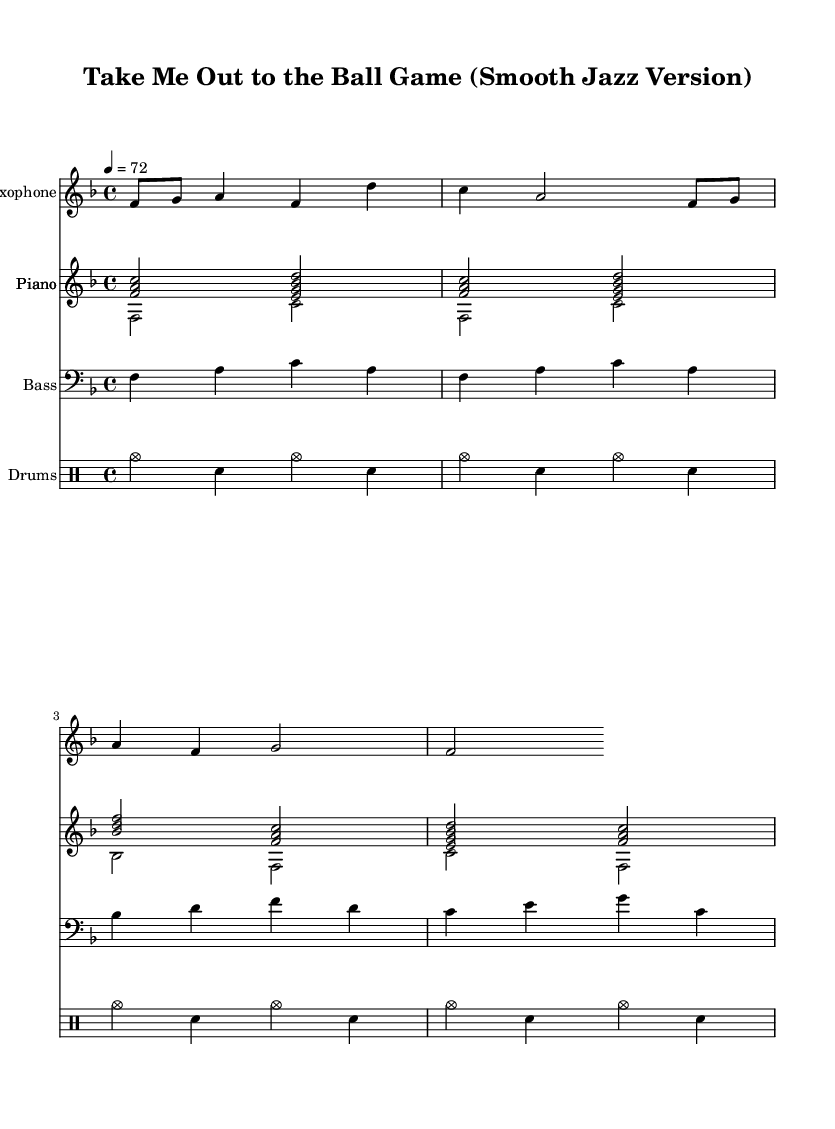What is the key signature of this music? The key signature indicates F major, which has one flat (B flat). This information is found at the beginning of the staff notation, where the flat symbol appears.
Answer: F major What is the time signature of this music? The time signature is indicated by the fraction at the beginning of the sheet music. In this case, it shows 4 over 4, meaning there are four beats in each measure.
Answer: 4/4 What is the tempo of this music? The tempo is shown next to the time signature, where it specifies '4 = 72', indicating that the quarter note equals 72 beats per minute.
Answer: 72 How many measures are in the saxophone part? To determine the number of measures, count the distinct sections or slashes that separate the musical phrases, leading to a total count. In this interpretation, there are four measures.
Answer: 4 Which instrument plays the melody primarily? The saxophone plays the leading melodic line in this arrangement, as it’s the first instrument featured and has distinct melodic phrases above the other parts.
Answer: Saxophone What is the role of the piano in this piece? The piano plays both harmonic chords and a rhythmic accompaniment, providing both structure and support for the melody. This can be observed from the chord progressions displayed in its staff.
Answer: Harmonic accompaniment What style is this arrangement showcasing? This arrangement combines jazz elements with a famous sports anthem, translating the original lively fight song into a smooth jazz style, evident from the rhythm and harmony used.
Answer: Smooth jazz 